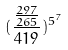Convert formula to latex. <formula><loc_0><loc_0><loc_500><loc_500>( \frac { \frac { 2 9 7 } { 2 6 5 } } { 4 1 9 } ) ^ { 5 ^ { 7 } }</formula> 